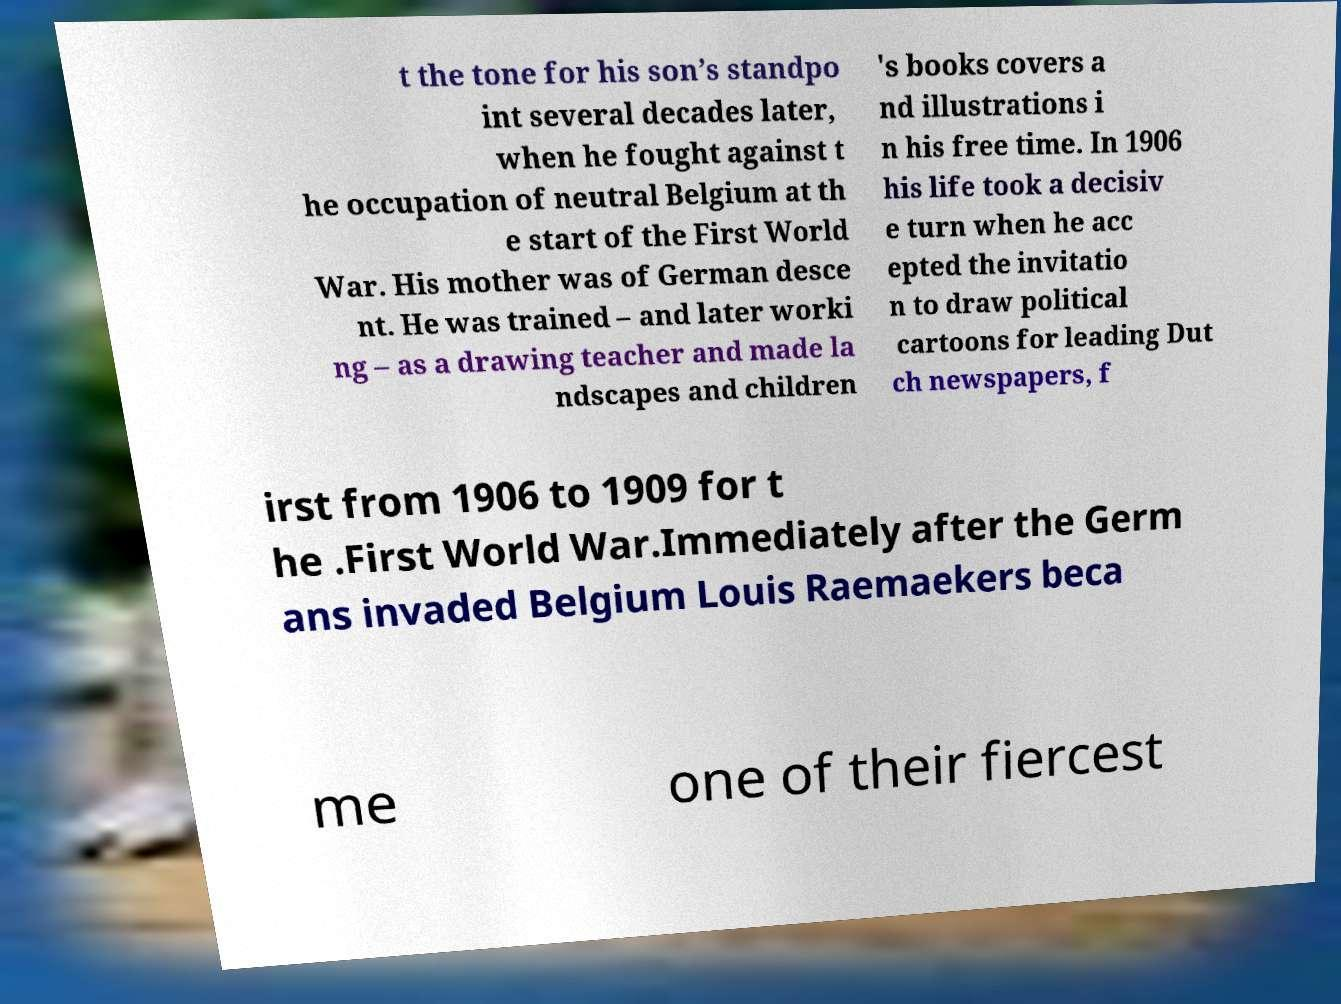I need the written content from this picture converted into text. Can you do that? t the tone for his son’s standpo int several decades later, when he fought against t he occupation of neutral Belgium at th e start of the First World War. His mother was of German desce nt. He was trained – and later worki ng – as a drawing teacher and made la ndscapes and children 's books covers a nd illustrations i n his free time. In 1906 his life took a decisiv e turn when he acc epted the invitatio n to draw political cartoons for leading Dut ch newspapers, f irst from 1906 to 1909 for t he .First World War.Immediately after the Germ ans invaded Belgium Louis Raemaekers beca me one of their fiercest 